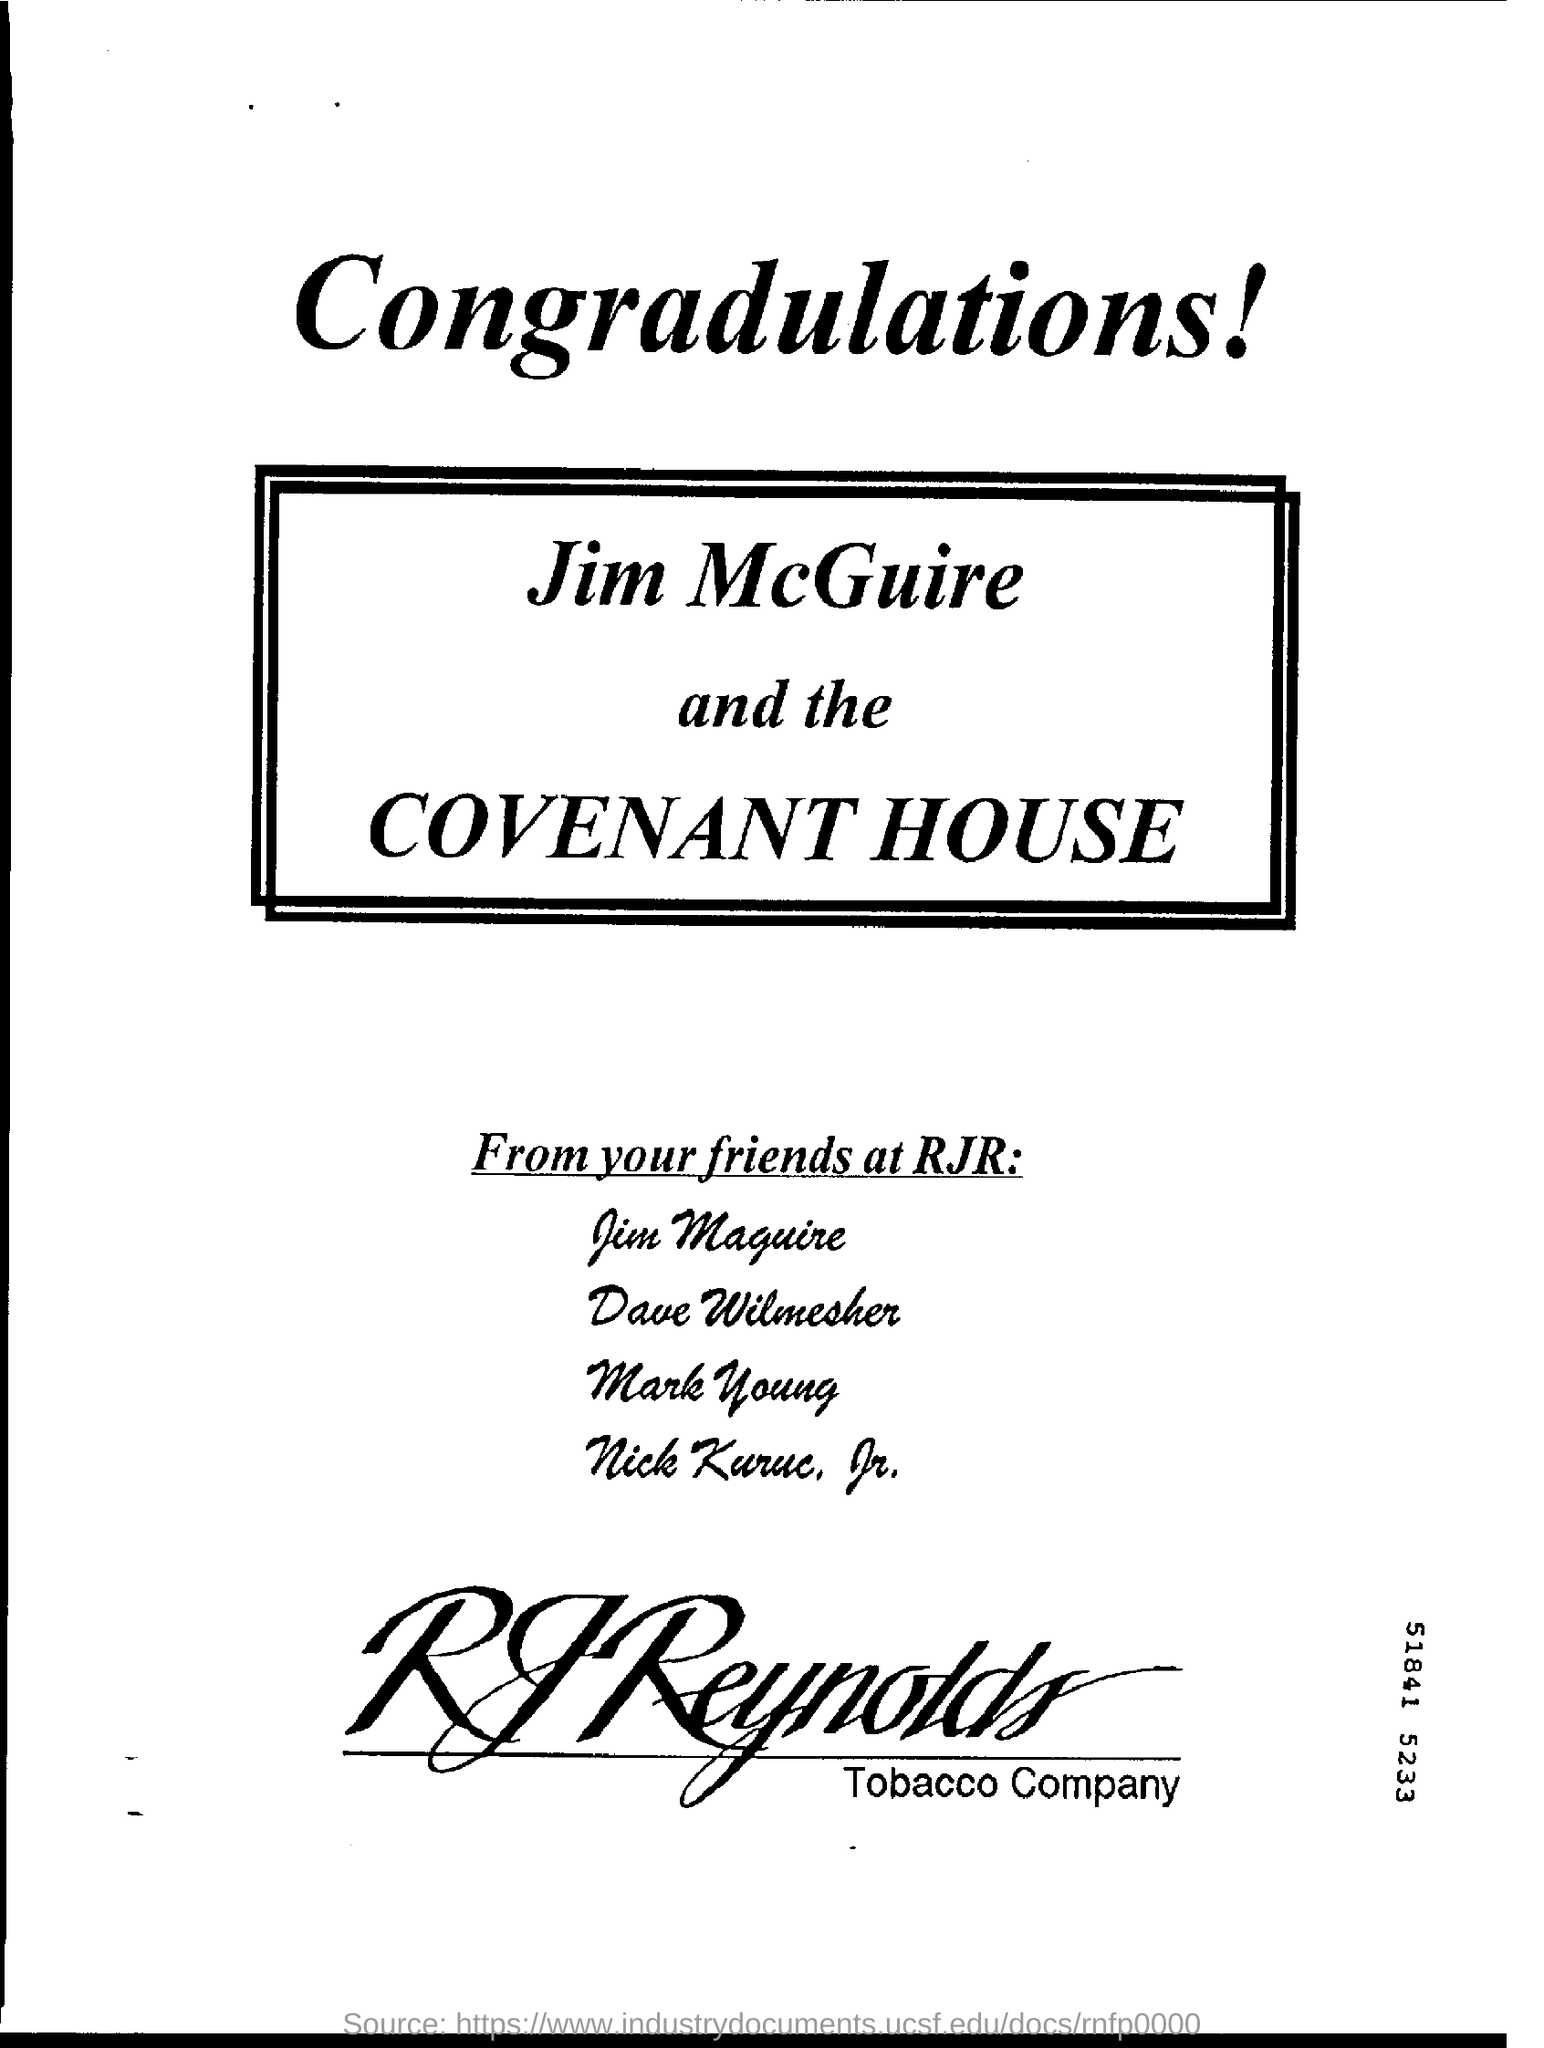Highlight a few significant elements in this photo. Reynolds Tobacco Company is a well-known tobacco company that is commonly referred to as RJR. 